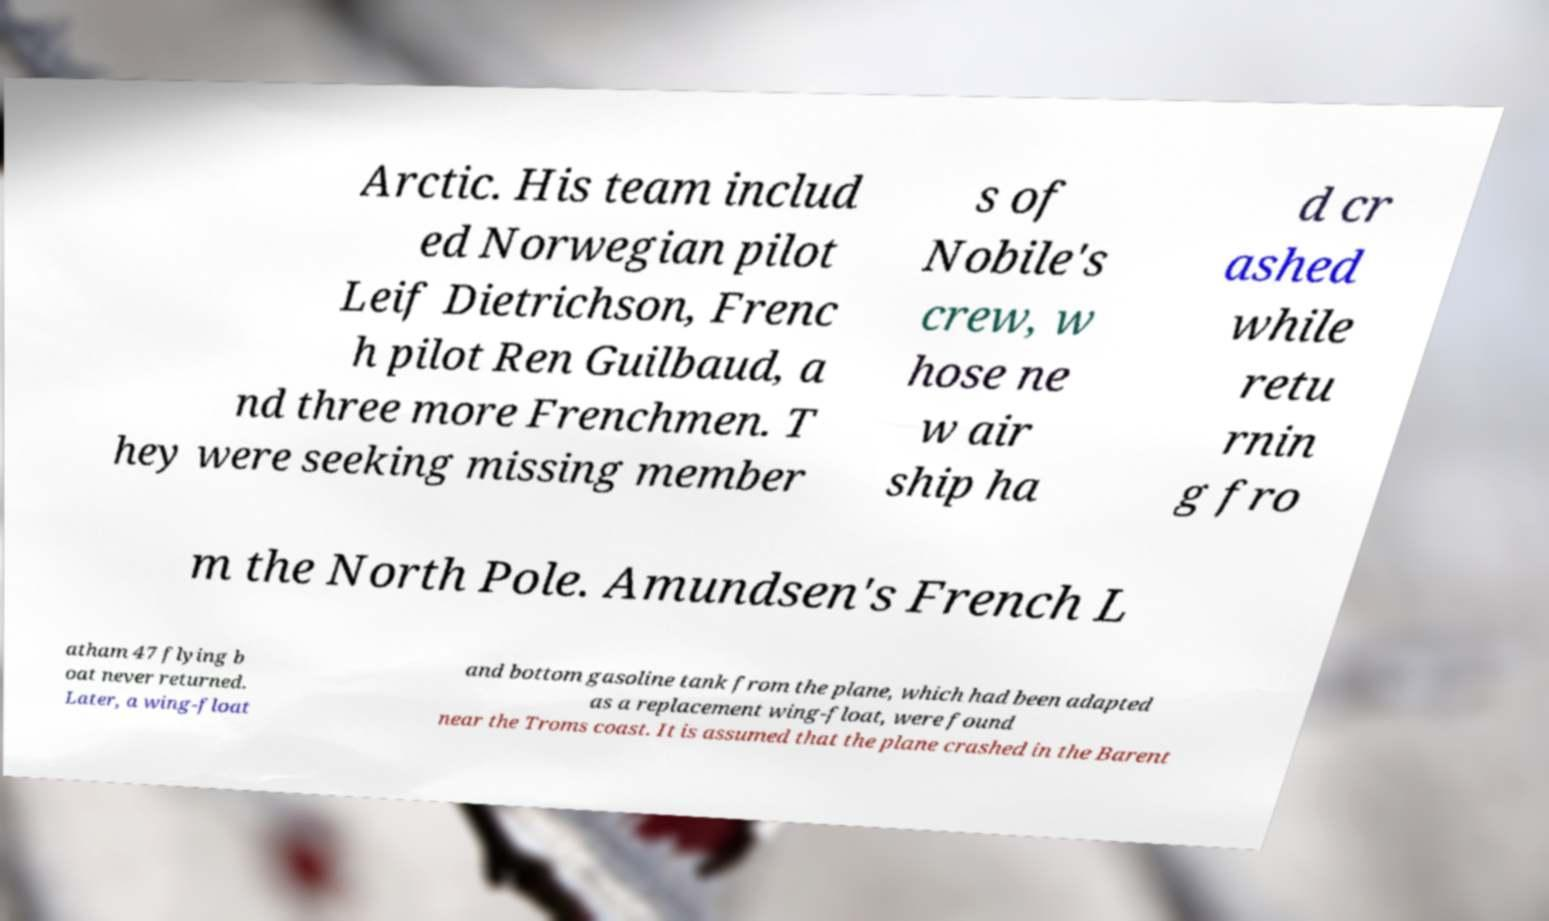What messages or text are displayed in this image? I need them in a readable, typed format. Arctic. His team includ ed Norwegian pilot Leif Dietrichson, Frenc h pilot Ren Guilbaud, a nd three more Frenchmen. T hey were seeking missing member s of Nobile's crew, w hose ne w air ship ha d cr ashed while retu rnin g fro m the North Pole. Amundsen's French L atham 47 flying b oat never returned. Later, a wing-float and bottom gasoline tank from the plane, which had been adapted as a replacement wing-float, were found near the Troms coast. It is assumed that the plane crashed in the Barent 